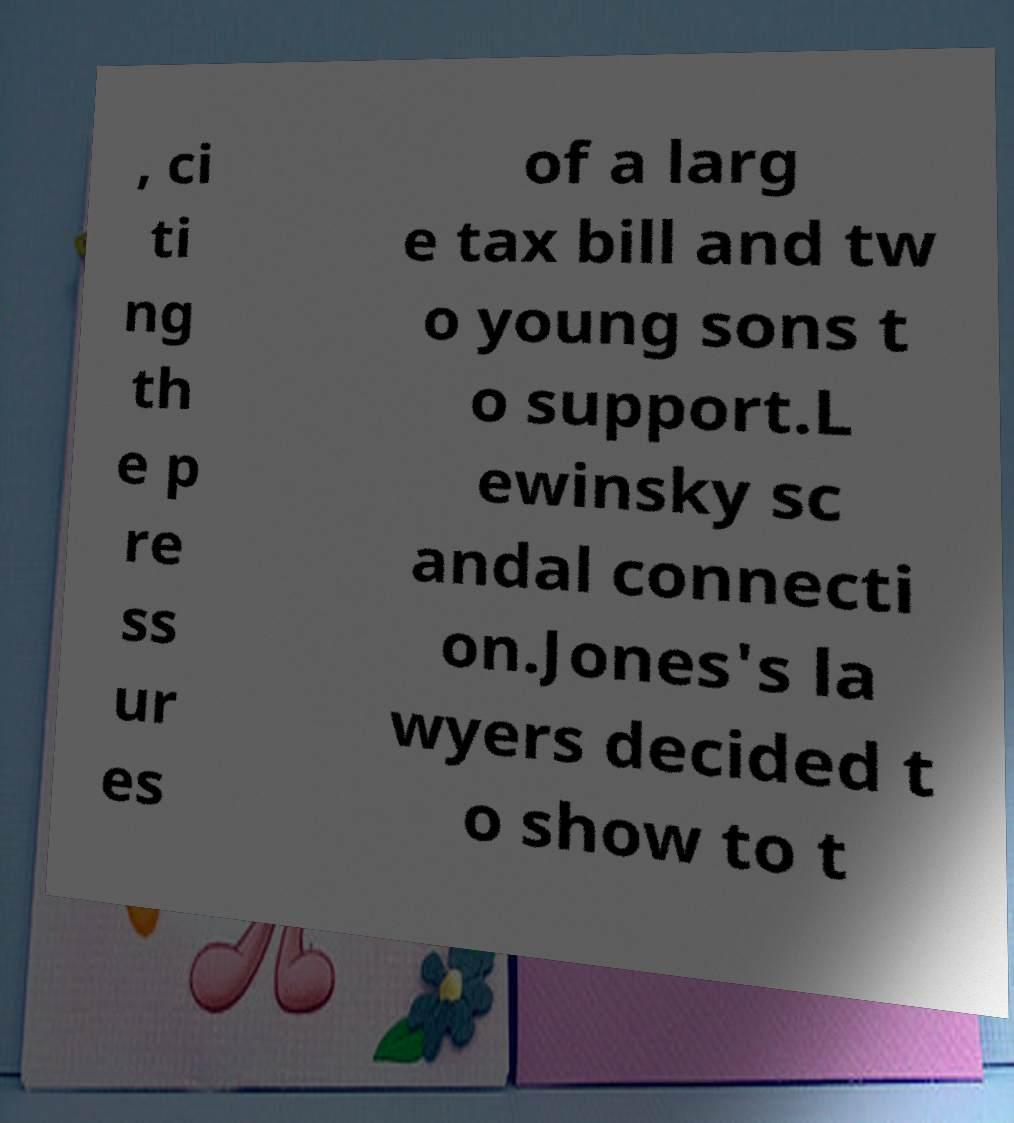Please read and relay the text visible in this image. What does it say? , ci ti ng th e p re ss ur es of a larg e tax bill and tw o young sons t o support.L ewinsky sc andal connecti on.Jones's la wyers decided t o show to t 